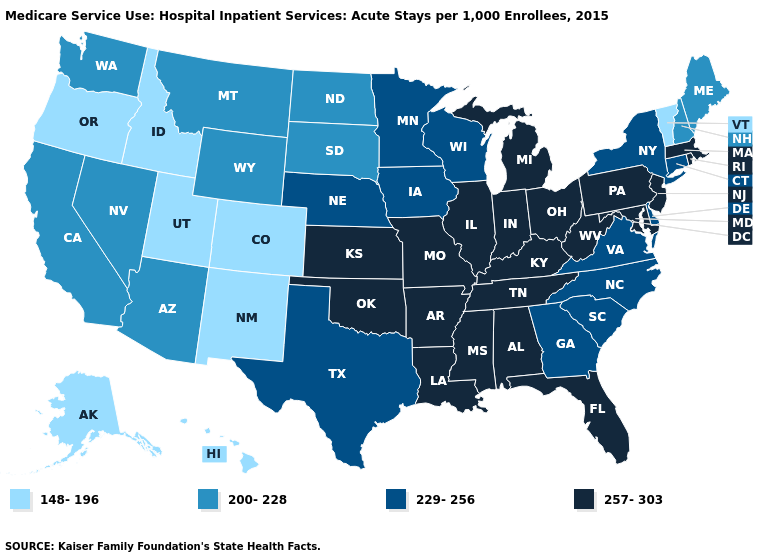What is the value of Idaho?
Short answer required. 148-196. Name the states that have a value in the range 200-228?
Quick response, please. Arizona, California, Maine, Montana, Nevada, New Hampshire, North Dakota, South Dakota, Washington, Wyoming. Is the legend a continuous bar?
Write a very short answer. No. Among the states that border Nevada , which have the highest value?
Short answer required. Arizona, California. Does the map have missing data?
Short answer required. No. What is the highest value in the USA?
Keep it brief. 257-303. Among the states that border Minnesota , which have the lowest value?
Short answer required. North Dakota, South Dakota. Does the first symbol in the legend represent the smallest category?
Be succinct. Yes. What is the value of Florida?
Concise answer only. 257-303. Is the legend a continuous bar?
Concise answer only. No. What is the value of South Dakota?
Short answer required. 200-228. Does Idaho have a lower value than Washington?
Short answer required. Yes. Name the states that have a value in the range 148-196?
Concise answer only. Alaska, Colorado, Hawaii, Idaho, New Mexico, Oregon, Utah, Vermont. What is the value of Arizona?
Quick response, please. 200-228. Does Arkansas have a higher value than Virginia?
Quick response, please. Yes. 